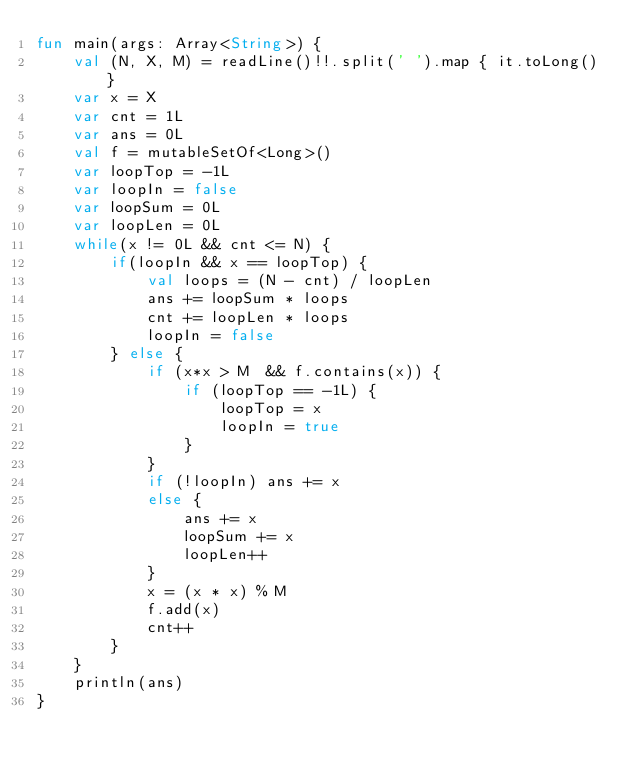Convert code to text. <code><loc_0><loc_0><loc_500><loc_500><_Kotlin_>fun main(args: Array<String>) {
    val (N, X, M) = readLine()!!.split(' ').map { it.toLong() }
    var x = X
    var cnt = 1L
    var ans = 0L
    val f = mutableSetOf<Long>()
    var loopTop = -1L
    var loopIn = false
    var loopSum = 0L
    var loopLen = 0L
    while(x != 0L && cnt <= N) {
        if(loopIn && x == loopTop) {
            val loops = (N - cnt) / loopLen
            ans += loopSum * loops
            cnt += loopLen * loops
            loopIn = false
        } else {
            if (x*x > M  && f.contains(x)) {
                if (loopTop == -1L) {
                    loopTop = x
                    loopIn = true
                }
            }
            if (!loopIn) ans += x
            else {
                ans += x
                loopSum += x
                loopLen++
            }
            x = (x * x) % M
            f.add(x)
            cnt++
        }
    }
    println(ans)
}
</code> 